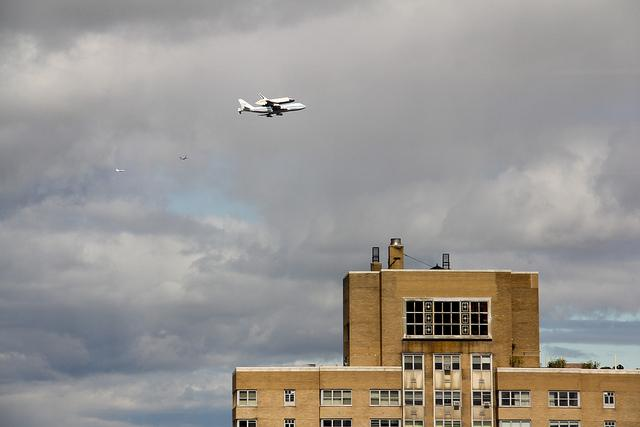What is the plane flying over? building 